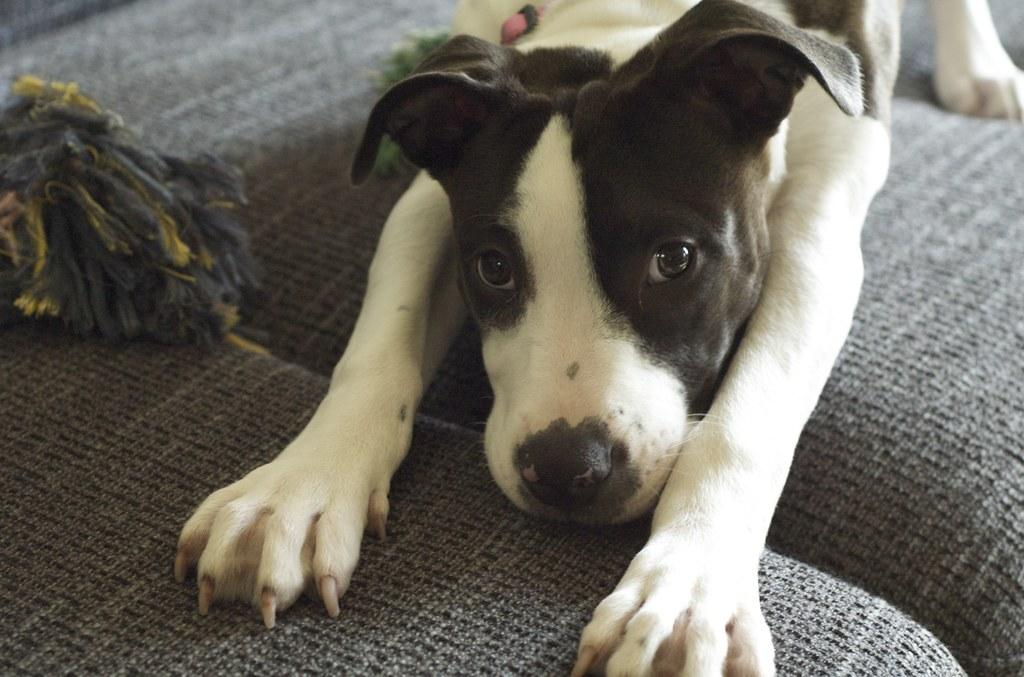What type of animal is present in the image? There is a dog in the image. Can you describe the object on the sofa in the image? Unfortunately, the facts provided do not give any information about the object on the sofa. How many buttons are on the dog's collar in the image? There is no mention of a collar or buttons in the provided facts, and therefore we cannot answer this question. Are there any bikes visible in the image? There is no mention of bikes in the provided facts, and therefore we cannot answer this question. 